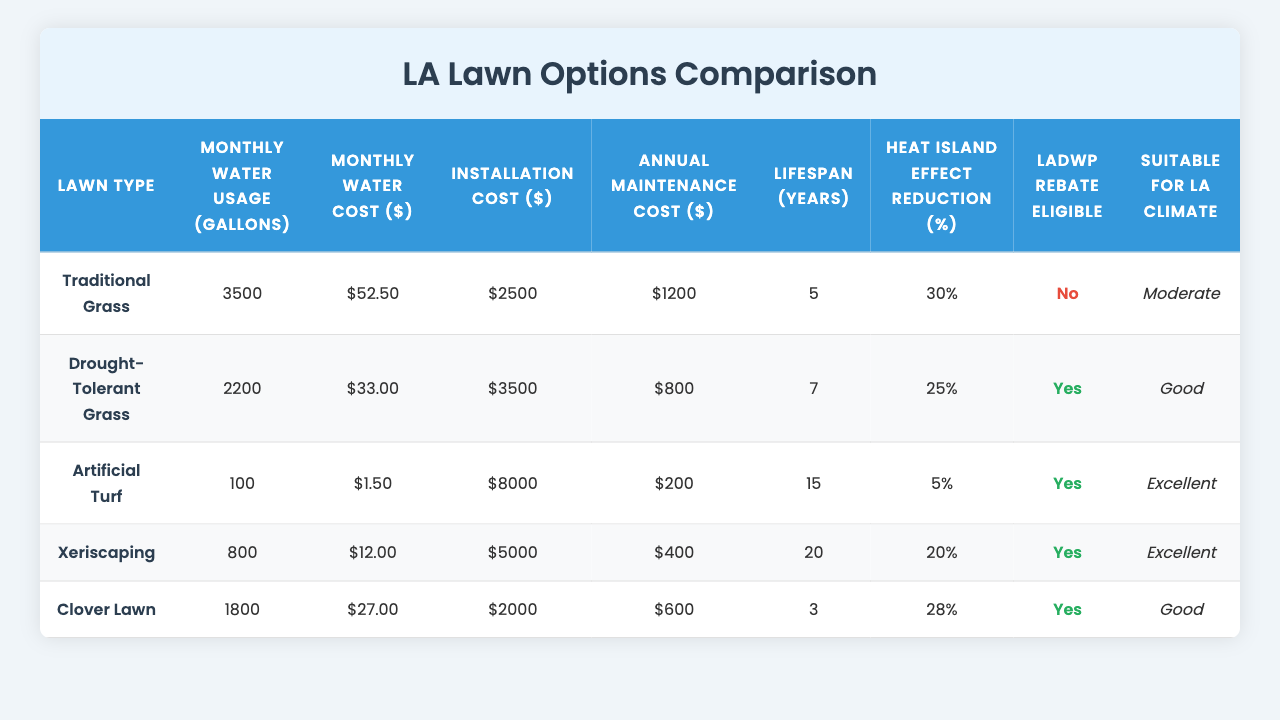What type of lawn has the lowest monthly water usage? The table shows that "Artificial Turf" has the lowest monthly water usage at 100 gallons.
Answer: Artificial Turf What is the monthly water cost for a Drought-Tolerant Grass lawn? According to the table, the monthly water cost for "Drought-Tolerant Grass" is $33.00.
Answer: $33.00 Is Clover Lawn eligible for LADWP rebate? The table indicates that "Clover Lawn" is not eligible for LADWP rebate, as it is marked with a "No."
Answer: No What is the installation cost difference between Traditional Grass and Xeriscaping? The installation cost for "Traditional Grass" is $2500, and for "Xeriscaping" it is $5000. The difference is $5000 - $2500 = $2500.
Answer: $2500 Which lawn type has the longest lifespan? The table shows that "Xeriscaping" has the longest lifespan of 20 years.
Answer: Xeriscaping What is the average monthly water cost for all lawn types combined? To find the average, sum the monthly water costs: $52.50 + $33.00 + $1.50 + $12.00 + $27.00 = $126.00. There are 5 lawn types, so the average is $126.00 / 5 = $25.20.
Answer: $25.20 Which lawn type has the highest Heat Island Effect Reduction? The table indicates that "Traditional Grass" has the highest effect reduction at 30%.
Answer: Traditional Grass How many lawn types are suitable for the LA climate rated as "Excellent"? The table shows that "Artificial Turf" and "Xeriscaping" are rated "Excellent," making a total of 2 types.
Answer: 2 What is the total annual maintenance cost for all lawn types? The annual maintenance costs are $1200 + $800 + $200 + $400 + $600 = $3200.
Answer: $3200 Which lawn type is the most cost-effective in terms of installation cost to monthly water cost ratio? For the calculation, we will divide the installation cost by the monthly water cost for each type. The ratios are: Traditional Grass: 2500/52.50 = 47.62, Drought-Tolerant Grass: 3500/33.00 = 106.06, Artificial Turf: 8000/1.50 = 5333.33, Xeriscaping: 5000/12.00 = 416.67, Clover Lawn: 2000/27.00 = 74.07. The lowest ratio is for Traditional Grass at 47.62, making it the most cost-effective.
Answer: Traditional Grass 